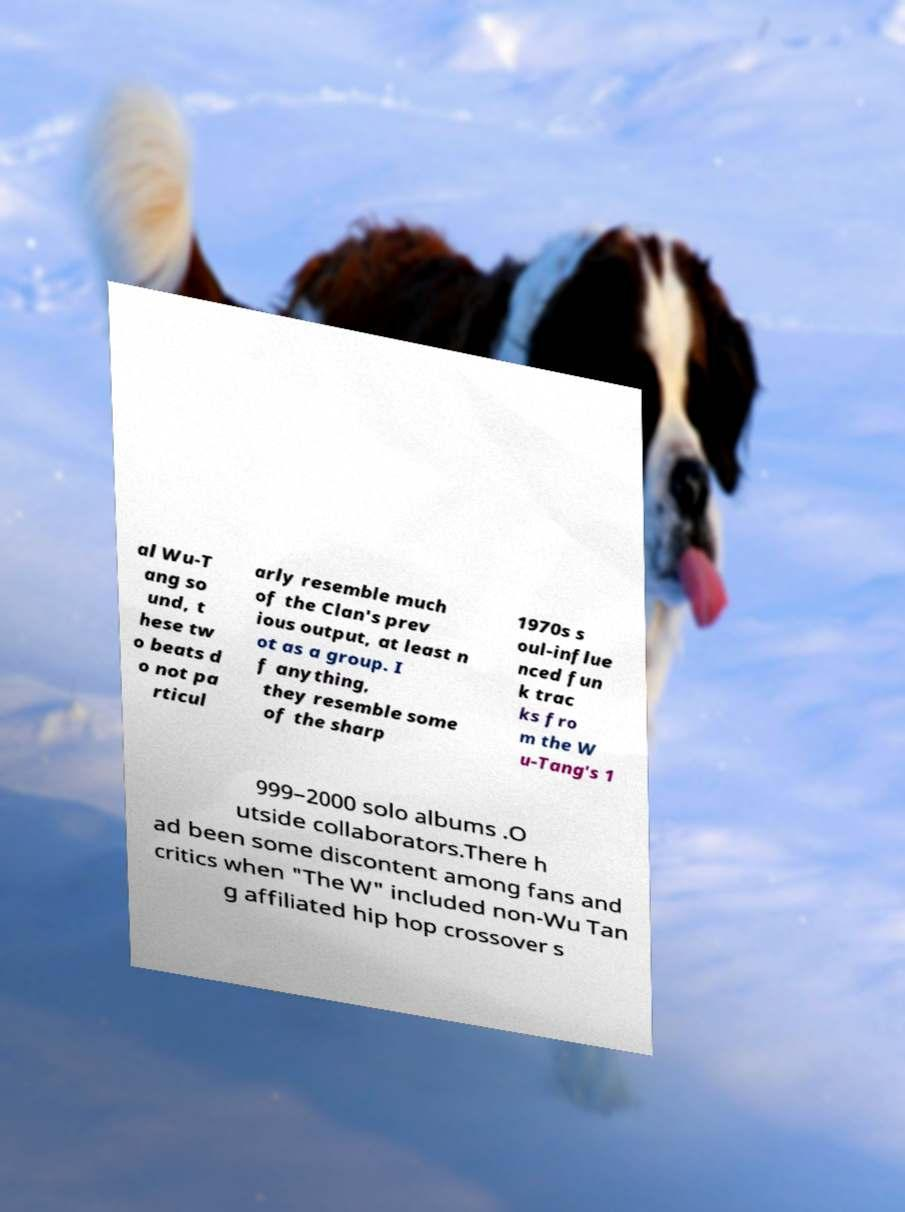Please read and relay the text visible in this image. What does it say? al Wu-T ang so und, t hese tw o beats d o not pa rticul arly resemble much of the Clan's prev ious output, at least n ot as a group. I f anything, they resemble some of the sharp 1970s s oul-influe nced fun k trac ks fro m the W u-Tang's 1 999–2000 solo albums .O utside collaborators.There h ad been some discontent among fans and critics when "The W" included non-Wu Tan g affiliated hip hop crossover s 